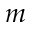Convert formula to latex. <formula><loc_0><loc_0><loc_500><loc_500>m</formula> 